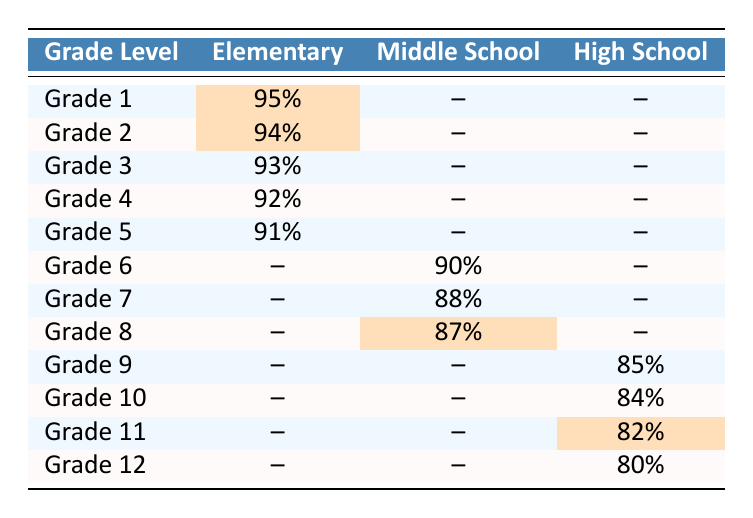What is the attendance rate for Grade 1 in the Englewood District? According to the table, the attendance rate for Grade 1 is 95%, which is explicitly listed under Elementary.
Answer: 95% Which grade in Middle School has the highest attendance rate? The table shows that Grade 8 has the highest attendance rate of 87% among the middle school grades.
Answer: Grade 8 Do any grades in Elementary have attendance rates highlighted? Yes, Grades 1 and 2 have highlighted attendance rates of 95% and 94%, respectively.
Answer: Yes What is the average attendance rate across all Elementary grades? The attendance rates for Elementary grades are 95%, 94%, 93%, 92%, and 91%. To find the average, sum these values: (95 + 94 + 93 + 92 + 91) = 465, then divide by the number of grades (5): 465 / 5 = 93%.
Answer: 93% What is the difference in attendance rates between Grade 11 and Grade 12 in High School? Grade 11 has an attendance rate of 82%, while Grade 12 has 80%. The difference is 82 - 80 = 2%.
Answer: 2% Are there any grades in High School with highlighted attendance rates? Yes, Grade 11 has a highlighted attendance rate of 82%.
Answer: Yes What is the overall attendance rate for Middle School grades? To find the overall attendance rate, the rates for Grades 6, 7, and 8 are summed: (90 + 88 + 87) = 265, and then divided by 3: 265 / 3 = 88.33%.
Answer: 88.33% Which grade has the lowest attendance rate in the table? The lowest attendance rate is 80%, which belongs to Grade 12 in High School.
Answer: Grade 12 Is the attendance rate for Grade 3 higher than that of Grade 8? Grade 3 has an attendance rate of 93%, and Grade 8 has an attendance rate of 87%. Since 93% is greater than 87%, the statement is true.
Answer: Yes What is the total of attendance rates for all grades in Elementary? The total attendance rates for Elementary grades are 95%, 94%, 93%, 92%, and 91%. Adding these rates gives: 95 + 94 + 93 + 92 + 91 = 465%.
Answer: 465% 